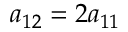<formula> <loc_0><loc_0><loc_500><loc_500>a _ { 1 2 } = 2 a _ { 1 1 }</formula> 